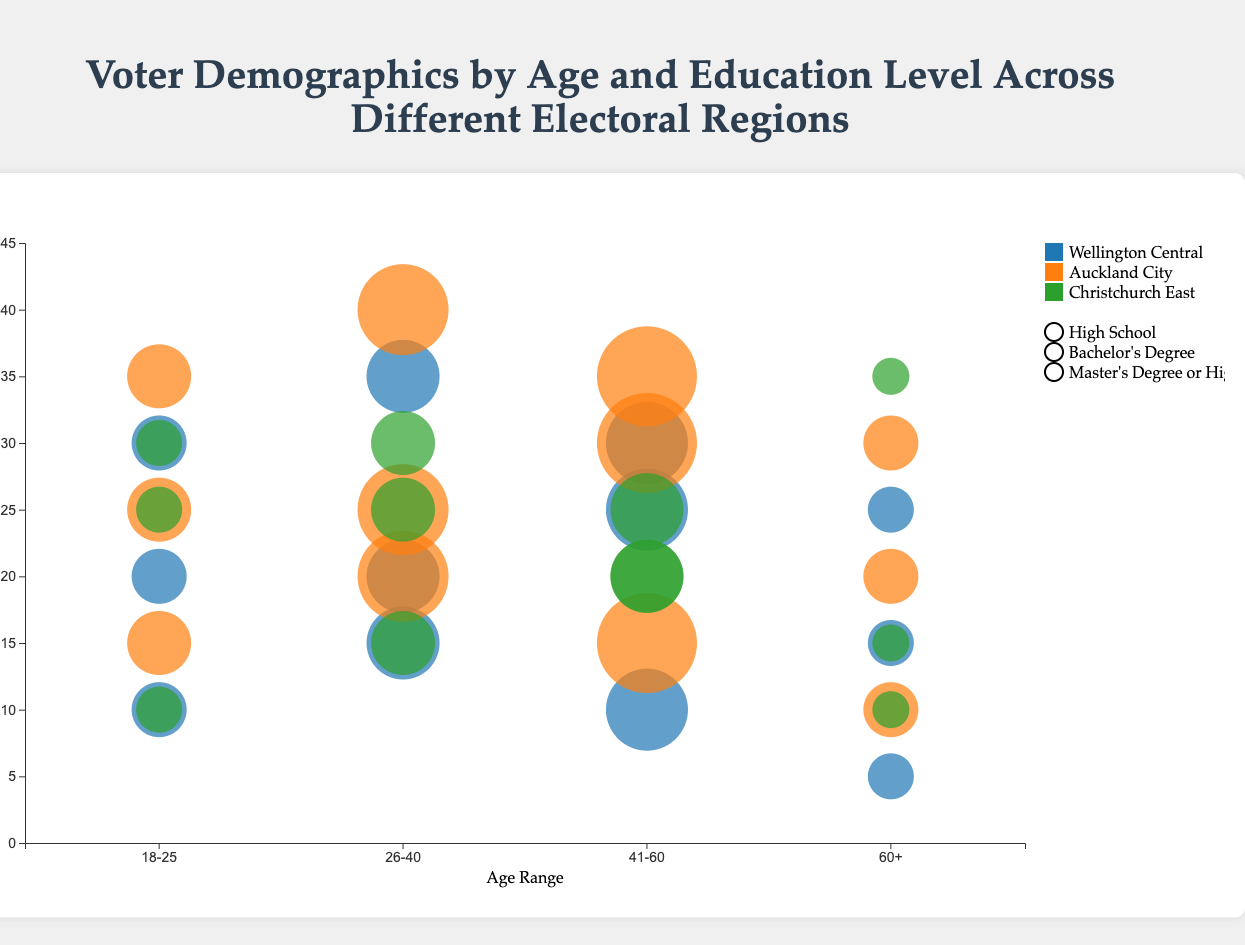How does voter education level among 26-40-year-olds in Wellington Central compare to those in Auckland City? To answer this, we analyze the bubbles for the 26-40 age group in both regions. In Wellington Central, Bachelor's Degree voters represent 35%, High School 15%, and Master's or higher 20%. In Auckland City, the shares are 40% (Bachelor's), 20% (High School), and 25% (Master's or higher). Bachelor's Degree and Master's share is higher in Auckland City, while High School percentage is lower in both regions.
Answer: Auckland City has higher Bachelor's and Master's degree percentages and a higher percentage of 26-40 age voters with a high school education than Wellington Central What is the most represented education level among 18-25-year-olds in Christchurch East? We look at the bubbles in Christchurch East for 18-25-year-olds. High School has 30%, Bachelor's Degree 25%, and Master's or higher 10%. Hence, High School has the highest representation.
Answer: High School Which region has the highest percentage of 60+ voters with a High School education? We compare the bubbles for the 60+ age group across all regions. In Wellington Central, it's 25%; in Auckland City, it's 30%, and in Christchurch East, it's 35%. Christchurch East has the highest percentage.
Answer: Christchurch East What is the total number of voters in the 41-60 age group for Wellington Central? To find this value, sum the total voters in this age range across different education levels in Wellington Central: 8000 (total). The calculation is straightforward since they are given.
Answer: 8000 Which age group in Auckland City has the highest total number of voters? We sum the voter counts for each age group: 18-25 (6000), 26-40 (9000), 41-60 (10000), 60+ (5000). The 41-60 age group has the highest total.
Answer: 41-60 How does the voter percentage with a Master's degree or higher among 41-60-year-olds in Wellington Central compare to Auckland City? For the 41-60 age group, the percentage in Wellington Central is 30%; in Auckland City, it is 35%. Therefore, the percentage is higher in Auckland City.
Answer: Auckland City Which region has the highest percentage of voters with Bachelor's degrees in the 26-40 age range? We compare the percentages in this age range: Wellington Central (35%), Auckland City (40%), and Christchurch East (30%). Auckland City has the highest.
Answer: Auckland City What is the difference in the percentage of voters with a High School education between 60+ and 18-25 age groups in Christchurch East? The percentage of high school educated voters among 60+ is 35% and among 18-25 is 30%. The difference is 35% - 30% = 5%.
Answer: 5% 